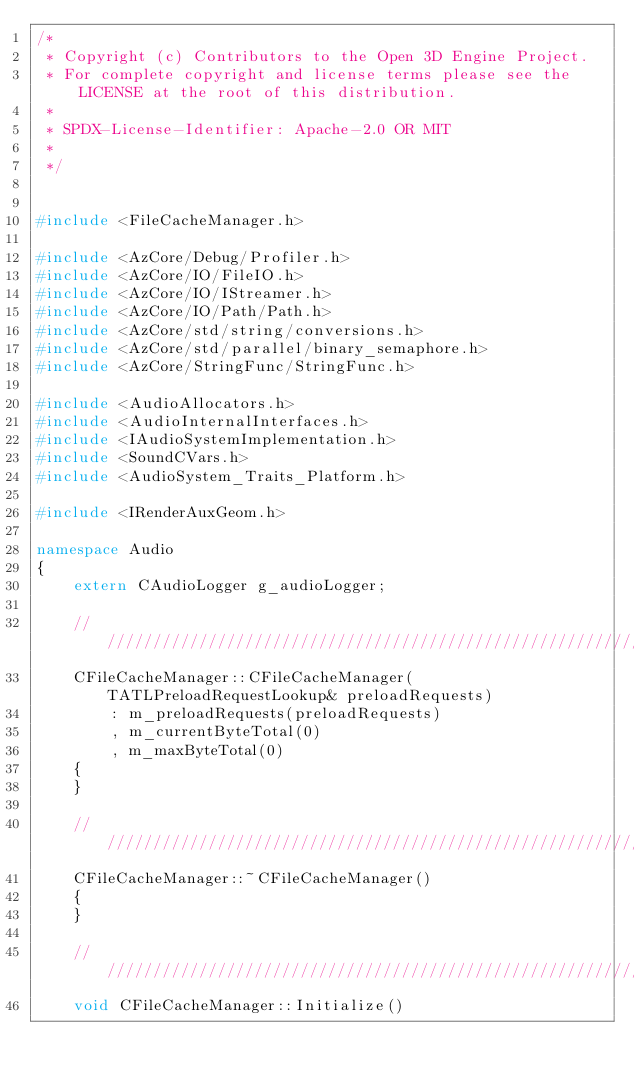Convert code to text. <code><loc_0><loc_0><loc_500><loc_500><_C++_>/*
 * Copyright (c) Contributors to the Open 3D Engine Project.
 * For complete copyright and license terms please see the LICENSE at the root of this distribution.
 *
 * SPDX-License-Identifier: Apache-2.0 OR MIT
 *
 */


#include <FileCacheManager.h>

#include <AzCore/Debug/Profiler.h>
#include <AzCore/IO/FileIO.h>
#include <AzCore/IO/IStreamer.h>
#include <AzCore/IO/Path/Path.h>
#include <AzCore/std/string/conversions.h>
#include <AzCore/std/parallel/binary_semaphore.h>
#include <AzCore/StringFunc/StringFunc.h>

#include <AudioAllocators.h>
#include <AudioInternalInterfaces.h>
#include <IAudioSystemImplementation.h>
#include <SoundCVars.h>
#include <AudioSystem_Traits_Platform.h>

#include <IRenderAuxGeom.h>

namespace Audio
{
    extern CAudioLogger g_audioLogger;

    ///////////////////////////////////////////////////////////////////////////////////////////////
    CFileCacheManager::CFileCacheManager(TATLPreloadRequestLookup& preloadRequests)
        : m_preloadRequests(preloadRequests)
        , m_currentByteTotal(0)
        , m_maxByteTotal(0)
    {
    }

    ///////////////////////////////////////////////////////////////////////////////////////////////
    CFileCacheManager::~CFileCacheManager()
    {
    }

    ///////////////////////////////////////////////////////////////////////////////////////////////
    void CFileCacheManager::Initialize()</code> 